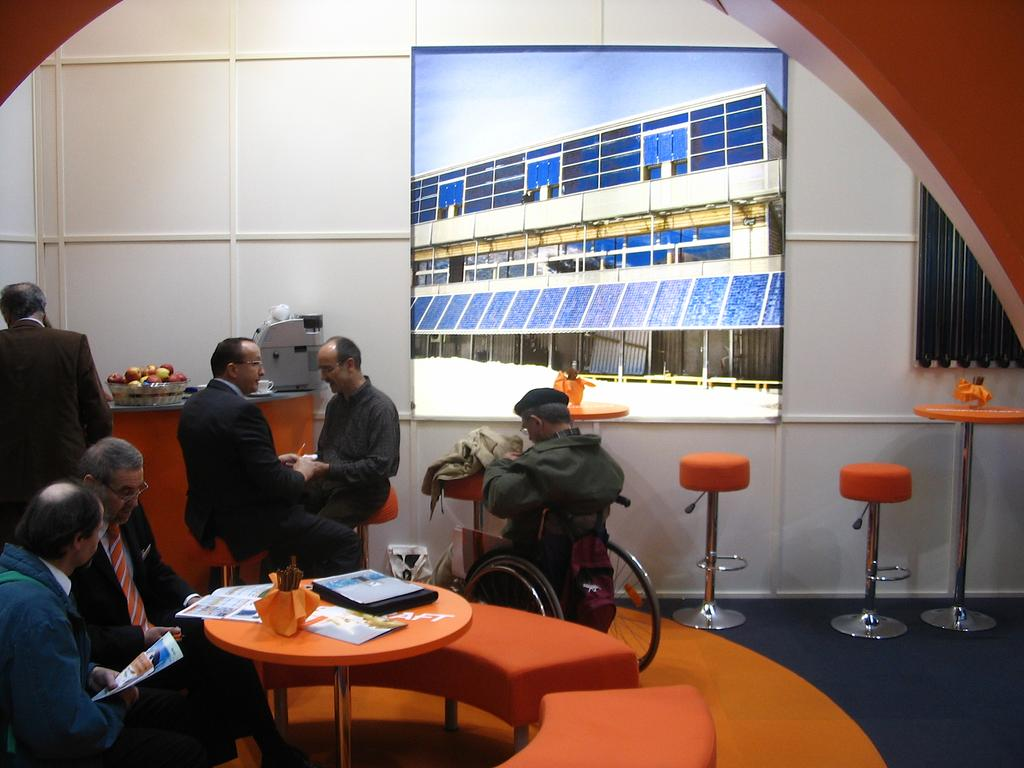What type of structure is visible in the image? There is a wall in the image. What device is present in the image? There is a screen in the image. Who or what is in front of the screen? There are people in the image. What piece of furniture is in the image? There is a table in the image. What electronic device is on the table? There is a laptop on the table. How many houses are visible in the image? There are no houses visible in the image. What type of bed is present in the image? There are no beds present in the image. 